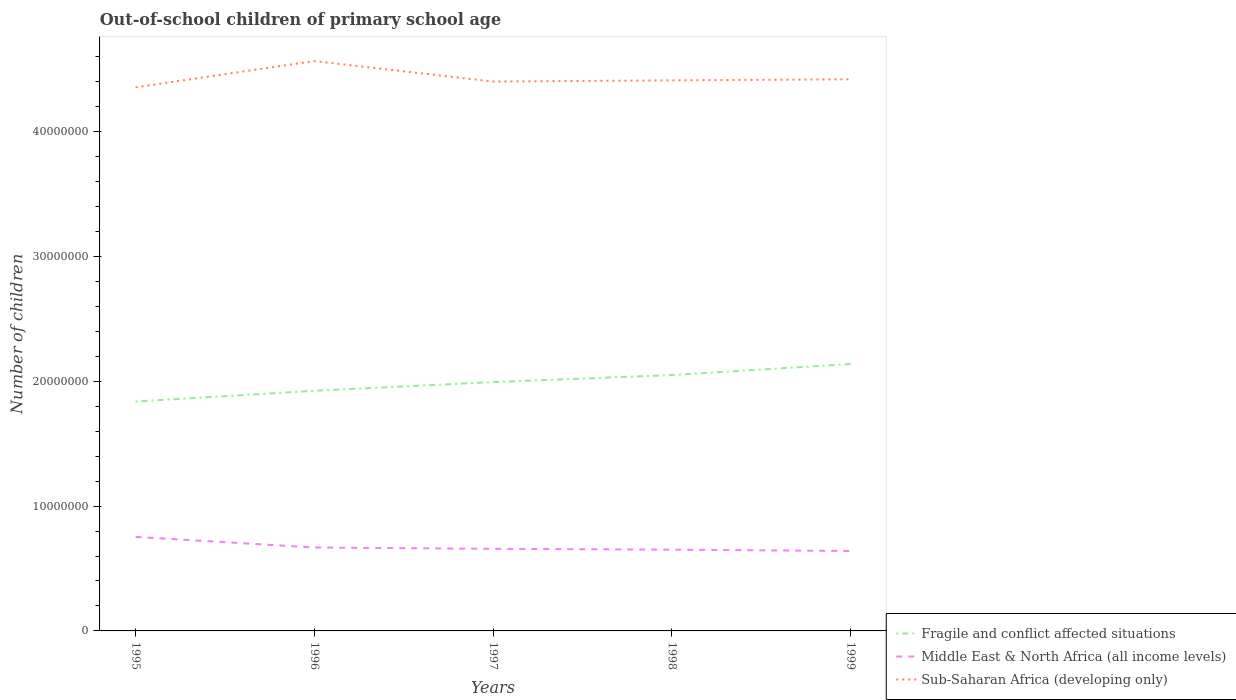Across all years, what is the maximum number of out-of-school children in Fragile and conflict affected situations?
Ensure brevity in your answer.  1.84e+07. What is the total number of out-of-school children in Sub-Saharan Africa (developing only) in the graph?
Your answer should be very brief. 1.54e+06. What is the difference between the highest and the second highest number of out-of-school children in Sub-Saharan Africa (developing only)?
Provide a short and direct response. 2.10e+06. What is the difference between the highest and the lowest number of out-of-school children in Fragile and conflict affected situations?
Ensure brevity in your answer.  3. Is the number of out-of-school children in Middle East & North Africa (all income levels) strictly greater than the number of out-of-school children in Sub-Saharan Africa (developing only) over the years?
Provide a short and direct response. Yes. How many years are there in the graph?
Give a very brief answer. 5. What is the difference between two consecutive major ticks on the Y-axis?
Make the answer very short. 1.00e+07. Does the graph contain grids?
Offer a terse response. No. How many legend labels are there?
Your answer should be very brief. 3. How are the legend labels stacked?
Provide a short and direct response. Vertical. What is the title of the graph?
Your answer should be compact. Out-of-school children of primary school age. What is the label or title of the Y-axis?
Give a very brief answer. Number of children. What is the Number of children in Fragile and conflict affected situations in 1995?
Make the answer very short. 1.84e+07. What is the Number of children of Middle East & North Africa (all income levels) in 1995?
Provide a short and direct response. 7.53e+06. What is the Number of children of Sub-Saharan Africa (developing only) in 1995?
Your answer should be compact. 4.35e+07. What is the Number of children in Fragile and conflict affected situations in 1996?
Keep it short and to the point. 1.92e+07. What is the Number of children of Middle East & North Africa (all income levels) in 1996?
Offer a very short reply. 6.68e+06. What is the Number of children in Sub-Saharan Africa (developing only) in 1996?
Provide a short and direct response. 4.56e+07. What is the Number of children of Fragile and conflict affected situations in 1997?
Your answer should be very brief. 1.99e+07. What is the Number of children in Middle East & North Africa (all income levels) in 1997?
Provide a succinct answer. 6.58e+06. What is the Number of children of Sub-Saharan Africa (developing only) in 1997?
Provide a succinct answer. 4.40e+07. What is the Number of children in Fragile and conflict affected situations in 1998?
Provide a short and direct response. 2.05e+07. What is the Number of children of Middle East & North Africa (all income levels) in 1998?
Provide a short and direct response. 6.51e+06. What is the Number of children of Sub-Saharan Africa (developing only) in 1998?
Give a very brief answer. 4.41e+07. What is the Number of children in Fragile and conflict affected situations in 1999?
Provide a succinct answer. 2.14e+07. What is the Number of children in Middle East & North Africa (all income levels) in 1999?
Your response must be concise. 6.40e+06. What is the Number of children in Sub-Saharan Africa (developing only) in 1999?
Provide a short and direct response. 4.42e+07. Across all years, what is the maximum Number of children of Fragile and conflict affected situations?
Provide a succinct answer. 2.14e+07. Across all years, what is the maximum Number of children of Middle East & North Africa (all income levels)?
Give a very brief answer. 7.53e+06. Across all years, what is the maximum Number of children of Sub-Saharan Africa (developing only)?
Your response must be concise. 4.56e+07. Across all years, what is the minimum Number of children in Fragile and conflict affected situations?
Give a very brief answer. 1.84e+07. Across all years, what is the minimum Number of children of Middle East & North Africa (all income levels)?
Keep it short and to the point. 6.40e+06. Across all years, what is the minimum Number of children of Sub-Saharan Africa (developing only)?
Keep it short and to the point. 4.35e+07. What is the total Number of children in Fragile and conflict affected situations in the graph?
Make the answer very short. 9.94e+07. What is the total Number of children of Middle East & North Africa (all income levels) in the graph?
Provide a short and direct response. 3.37e+07. What is the total Number of children of Sub-Saharan Africa (developing only) in the graph?
Offer a terse response. 2.21e+08. What is the difference between the Number of children in Fragile and conflict affected situations in 1995 and that in 1996?
Your answer should be compact. -8.56e+05. What is the difference between the Number of children of Middle East & North Africa (all income levels) in 1995 and that in 1996?
Your answer should be very brief. 8.50e+05. What is the difference between the Number of children of Sub-Saharan Africa (developing only) in 1995 and that in 1996?
Your answer should be compact. -2.10e+06. What is the difference between the Number of children of Fragile and conflict affected situations in 1995 and that in 1997?
Offer a terse response. -1.56e+06. What is the difference between the Number of children in Middle East & North Africa (all income levels) in 1995 and that in 1997?
Give a very brief answer. 9.55e+05. What is the difference between the Number of children in Sub-Saharan Africa (developing only) in 1995 and that in 1997?
Give a very brief answer. -4.59e+05. What is the difference between the Number of children of Fragile and conflict affected situations in 1995 and that in 1998?
Provide a short and direct response. -2.12e+06. What is the difference between the Number of children in Middle East & North Africa (all income levels) in 1995 and that in 1998?
Offer a terse response. 1.02e+06. What is the difference between the Number of children of Sub-Saharan Africa (developing only) in 1995 and that in 1998?
Keep it short and to the point. -5.56e+05. What is the difference between the Number of children in Fragile and conflict affected situations in 1995 and that in 1999?
Make the answer very short. -3.00e+06. What is the difference between the Number of children in Middle East & North Africa (all income levels) in 1995 and that in 1999?
Provide a succinct answer. 1.13e+06. What is the difference between the Number of children in Sub-Saharan Africa (developing only) in 1995 and that in 1999?
Keep it short and to the point. -6.39e+05. What is the difference between the Number of children in Fragile and conflict affected situations in 1996 and that in 1997?
Ensure brevity in your answer.  -7.00e+05. What is the difference between the Number of children of Middle East & North Africa (all income levels) in 1996 and that in 1997?
Give a very brief answer. 1.06e+05. What is the difference between the Number of children of Sub-Saharan Africa (developing only) in 1996 and that in 1997?
Make the answer very short. 1.64e+06. What is the difference between the Number of children in Fragile and conflict affected situations in 1996 and that in 1998?
Provide a short and direct response. -1.26e+06. What is the difference between the Number of children in Middle East & North Africa (all income levels) in 1996 and that in 1998?
Ensure brevity in your answer.  1.74e+05. What is the difference between the Number of children in Sub-Saharan Africa (developing only) in 1996 and that in 1998?
Offer a terse response. 1.54e+06. What is the difference between the Number of children in Fragile and conflict affected situations in 1996 and that in 1999?
Ensure brevity in your answer.  -2.15e+06. What is the difference between the Number of children of Middle East & North Africa (all income levels) in 1996 and that in 1999?
Your response must be concise. 2.80e+05. What is the difference between the Number of children of Sub-Saharan Africa (developing only) in 1996 and that in 1999?
Your answer should be very brief. 1.46e+06. What is the difference between the Number of children of Fragile and conflict affected situations in 1997 and that in 1998?
Make the answer very short. -5.61e+05. What is the difference between the Number of children in Middle East & North Africa (all income levels) in 1997 and that in 1998?
Keep it short and to the point. 6.80e+04. What is the difference between the Number of children of Sub-Saharan Africa (developing only) in 1997 and that in 1998?
Give a very brief answer. -9.67e+04. What is the difference between the Number of children of Fragile and conflict affected situations in 1997 and that in 1999?
Provide a succinct answer. -1.45e+06. What is the difference between the Number of children in Middle East & North Africa (all income levels) in 1997 and that in 1999?
Make the answer very short. 1.75e+05. What is the difference between the Number of children in Sub-Saharan Africa (developing only) in 1997 and that in 1999?
Make the answer very short. -1.79e+05. What is the difference between the Number of children in Fragile and conflict affected situations in 1998 and that in 1999?
Your answer should be very brief. -8.86e+05. What is the difference between the Number of children in Middle East & North Africa (all income levels) in 1998 and that in 1999?
Your answer should be very brief. 1.07e+05. What is the difference between the Number of children of Sub-Saharan Africa (developing only) in 1998 and that in 1999?
Ensure brevity in your answer.  -8.28e+04. What is the difference between the Number of children of Fragile and conflict affected situations in 1995 and the Number of children of Middle East & North Africa (all income levels) in 1996?
Your answer should be very brief. 1.17e+07. What is the difference between the Number of children of Fragile and conflict affected situations in 1995 and the Number of children of Sub-Saharan Africa (developing only) in 1996?
Give a very brief answer. -2.73e+07. What is the difference between the Number of children in Middle East & North Africa (all income levels) in 1995 and the Number of children in Sub-Saharan Africa (developing only) in 1996?
Offer a terse response. -3.81e+07. What is the difference between the Number of children of Fragile and conflict affected situations in 1995 and the Number of children of Middle East & North Africa (all income levels) in 1997?
Offer a terse response. 1.18e+07. What is the difference between the Number of children in Fragile and conflict affected situations in 1995 and the Number of children in Sub-Saharan Africa (developing only) in 1997?
Your response must be concise. -2.56e+07. What is the difference between the Number of children of Middle East & North Africa (all income levels) in 1995 and the Number of children of Sub-Saharan Africa (developing only) in 1997?
Offer a very short reply. -3.65e+07. What is the difference between the Number of children of Fragile and conflict affected situations in 1995 and the Number of children of Middle East & North Africa (all income levels) in 1998?
Provide a short and direct response. 1.19e+07. What is the difference between the Number of children in Fragile and conflict affected situations in 1995 and the Number of children in Sub-Saharan Africa (developing only) in 1998?
Give a very brief answer. -2.57e+07. What is the difference between the Number of children in Middle East & North Africa (all income levels) in 1995 and the Number of children in Sub-Saharan Africa (developing only) in 1998?
Your response must be concise. -3.66e+07. What is the difference between the Number of children in Fragile and conflict affected situations in 1995 and the Number of children in Middle East & North Africa (all income levels) in 1999?
Provide a short and direct response. 1.20e+07. What is the difference between the Number of children of Fragile and conflict affected situations in 1995 and the Number of children of Sub-Saharan Africa (developing only) in 1999?
Provide a short and direct response. -2.58e+07. What is the difference between the Number of children in Middle East & North Africa (all income levels) in 1995 and the Number of children in Sub-Saharan Africa (developing only) in 1999?
Keep it short and to the point. -3.67e+07. What is the difference between the Number of children of Fragile and conflict affected situations in 1996 and the Number of children of Middle East & North Africa (all income levels) in 1997?
Provide a short and direct response. 1.27e+07. What is the difference between the Number of children in Fragile and conflict affected situations in 1996 and the Number of children in Sub-Saharan Africa (developing only) in 1997?
Give a very brief answer. -2.48e+07. What is the difference between the Number of children in Middle East & North Africa (all income levels) in 1996 and the Number of children in Sub-Saharan Africa (developing only) in 1997?
Provide a succinct answer. -3.73e+07. What is the difference between the Number of children of Fragile and conflict affected situations in 1996 and the Number of children of Middle East & North Africa (all income levels) in 1998?
Your answer should be compact. 1.27e+07. What is the difference between the Number of children of Fragile and conflict affected situations in 1996 and the Number of children of Sub-Saharan Africa (developing only) in 1998?
Ensure brevity in your answer.  -2.49e+07. What is the difference between the Number of children of Middle East & North Africa (all income levels) in 1996 and the Number of children of Sub-Saharan Africa (developing only) in 1998?
Give a very brief answer. -3.74e+07. What is the difference between the Number of children in Fragile and conflict affected situations in 1996 and the Number of children in Middle East & North Africa (all income levels) in 1999?
Your answer should be compact. 1.28e+07. What is the difference between the Number of children in Fragile and conflict affected situations in 1996 and the Number of children in Sub-Saharan Africa (developing only) in 1999?
Provide a short and direct response. -2.50e+07. What is the difference between the Number of children of Middle East & North Africa (all income levels) in 1996 and the Number of children of Sub-Saharan Africa (developing only) in 1999?
Offer a terse response. -3.75e+07. What is the difference between the Number of children in Fragile and conflict affected situations in 1997 and the Number of children in Middle East & North Africa (all income levels) in 1998?
Keep it short and to the point. 1.34e+07. What is the difference between the Number of children of Fragile and conflict affected situations in 1997 and the Number of children of Sub-Saharan Africa (developing only) in 1998?
Your response must be concise. -2.42e+07. What is the difference between the Number of children in Middle East & North Africa (all income levels) in 1997 and the Number of children in Sub-Saharan Africa (developing only) in 1998?
Give a very brief answer. -3.75e+07. What is the difference between the Number of children of Fragile and conflict affected situations in 1997 and the Number of children of Middle East & North Africa (all income levels) in 1999?
Provide a succinct answer. 1.35e+07. What is the difference between the Number of children in Fragile and conflict affected situations in 1997 and the Number of children in Sub-Saharan Africa (developing only) in 1999?
Give a very brief answer. -2.43e+07. What is the difference between the Number of children in Middle East & North Africa (all income levels) in 1997 and the Number of children in Sub-Saharan Africa (developing only) in 1999?
Your response must be concise. -3.76e+07. What is the difference between the Number of children of Fragile and conflict affected situations in 1998 and the Number of children of Middle East & North Africa (all income levels) in 1999?
Give a very brief answer. 1.41e+07. What is the difference between the Number of children in Fragile and conflict affected situations in 1998 and the Number of children in Sub-Saharan Africa (developing only) in 1999?
Your answer should be very brief. -2.37e+07. What is the difference between the Number of children of Middle East & North Africa (all income levels) in 1998 and the Number of children of Sub-Saharan Africa (developing only) in 1999?
Keep it short and to the point. -3.77e+07. What is the average Number of children in Fragile and conflict affected situations per year?
Provide a succinct answer. 1.99e+07. What is the average Number of children of Middle East & North Africa (all income levels) per year?
Keep it short and to the point. 6.74e+06. What is the average Number of children of Sub-Saharan Africa (developing only) per year?
Ensure brevity in your answer.  4.43e+07. In the year 1995, what is the difference between the Number of children of Fragile and conflict affected situations and Number of children of Middle East & North Africa (all income levels)?
Keep it short and to the point. 1.08e+07. In the year 1995, what is the difference between the Number of children in Fragile and conflict affected situations and Number of children in Sub-Saharan Africa (developing only)?
Offer a terse response. -2.52e+07. In the year 1995, what is the difference between the Number of children in Middle East & North Africa (all income levels) and Number of children in Sub-Saharan Africa (developing only)?
Your answer should be compact. -3.60e+07. In the year 1996, what is the difference between the Number of children in Fragile and conflict affected situations and Number of children in Middle East & North Africa (all income levels)?
Your answer should be compact. 1.26e+07. In the year 1996, what is the difference between the Number of children of Fragile and conflict affected situations and Number of children of Sub-Saharan Africa (developing only)?
Give a very brief answer. -2.64e+07. In the year 1996, what is the difference between the Number of children in Middle East & North Africa (all income levels) and Number of children in Sub-Saharan Africa (developing only)?
Give a very brief answer. -3.90e+07. In the year 1997, what is the difference between the Number of children of Fragile and conflict affected situations and Number of children of Middle East & North Africa (all income levels)?
Give a very brief answer. 1.34e+07. In the year 1997, what is the difference between the Number of children of Fragile and conflict affected situations and Number of children of Sub-Saharan Africa (developing only)?
Your answer should be compact. -2.41e+07. In the year 1997, what is the difference between the Number of children of Middle East & North Africa (all income levels) and Number of children of Sub-Saharan Africa (developing only)?
Offer a terse response. -3.74e+07. In the year 1998, what is the difference between the Number of children in Fragile and conflict affected situations and Number of children in Middle East & North Africa (all income levels)?
Offer a very short reply. 1.40e+07. In the year 1998, what is the difference between the Number of children of Fragile and conflict affected situations and Number of children of Sub-Saharan Africa (developing only)?
Provide a succinct answer. -2.36e+07. In the year 1998, what is the difference between the Number of children of Middle East & North Africa (all income levels) and Number of children of Sub-Saharan Africa (developing only)?
Your answer should be compact. -3.76e+07. In the year 1999, what is the difference between the Number of children in Fragile and conflict affected situations and Number of children in Middle East & North Africa (all income levels)?
Your answer should be very brief. 1.50e+07. In the year 1999, what is the difference between the Number of children of Fragile and conflict affected situations and Number of children of Sub-Saharan Africa (developing only)?
Your response must be concise. -2.28e+07. In the year 1999, what is the difference between the Number of children of Middle East & North Africa (all income levels) and Number of children of Sub-Saharan Africa (developing only)?
Your response must be concise. -3.78e+07. What is the ratio of the Number of children in Fragile and conflict affected situations in 1995 to that in 1996?
Provide a short and direct response. 0.96. What is the ratio of the Number of children of Middle East & North Africa (all income levels) in 1995 to that in 1996?
Provide a short and direct response. 1.13. What is the ratio of the Number of children of Sub-Saharan Africa (developing only) in 1995 to that in 1996?
Give a very brief answer. 0.95. What is the ratio of the Number of children of Fragile and conflict affected situations in 1995 to that in 1997?
Offer a very short reply. 0.92. What is the ratio of the Number of children in Middle East & North Africa (all income levels) in 1995 to that in 1997?
Give a very brief answer. 1.15. What is the ratio of the Number of children of Fragile and conflict affected situations in 1995 to that in 1998?
Offer a terse response. 0.9. What is the ratio of the Number of children in Middle East & North Africa (all income levels) in 1995 to that in 1998?
Offer a very short reply. 1.16. What is the ratio of the Number of children of Sub-Saharan Africa (developing only) in 1995 to that in 1998?
Make the answer very short. 0.99. What is the ratio of the Number of children in Fragile and conflict affected situations in 1995 to that in 1999?
Ensure brevity in your answer.  0.86. What is the ratio of the Number of children in Middle East & North Africa (all income levels) in 1995 to that in 1999?
Give a very brief answer. 1.18. What is the ratio of the Number of children of Sub-Saharan Africa (developing only) in 1995 to that in 1999?
Ensure brevity in your answer.  0.99. What is the ratio of the Number of children of Fragile and conflict affected situations in 1996 to that in 1997?
Ensure brevity in your answer.  0.96. What is the ratio of the Number of children in Middle East & North Africa (all income levels) in 1996 to that in 1997?
Offer a very short reply. 1.02. What is the ratio of the Number of children of Sub-Saharan Africa (developing only) in 1996 to that in 1997?
Ensure brevity in your answer.  1.04. What is the ratio of the Number of children in Fragile and conflict affected situations in 1996 to that in 1998?
Provide a succinct answer. 0.94. What is the ratio of the Number of children in Middle East & North Africa (all income levels) in 1996 to that in 1998?
Make the answer very short. 1.03. What is the ratio of the Number of children of Sub-Saharan Africa (developing only) in 1996 to that in 1998?
Provide a succinct answer. 1.03. What is the ratio of the Number of children of Fragile and conflict affected situations in 1996 to that in 1999?
Make the answer very short. 0.9. What is the ratio of the Number of children in Middle East & North Africa (all income levels) in 1996 to that in 1999?
Keep it short and to the point. 1.04. What is the ratio of the Number of children in Sub-Saharan Africa (developing only) in 1996 to that in 1999?
Provide a succinct answer. 1.03. What is the ratio of the Number of children of Fragile and conflict affected situations in 1997 to that in 1998?
Ensure brevity in your answer.  0.97. What is the ratio of the Number of children of Middle East & North Africa (all income levels) in 1997 to that in 1998?
Keep it short and to the point. 1.01. What is the ratio of the Number of children of Sub-Saharan Africa (developing only) in 1997 to that in 1998?
Give a very brief answer. 1. What is the ratio of the Number of children of Fragile and conflict affected situations in 1997 to that in 1999?
Your answer should be compact. 0.93. What is the ratio of the Number of children in Middle East & North Africa (all income levels) in 1997 to that in 1999?
Provide a short and direct response. 1.03. What is the ratio of the Number of children in Fragile and conflict affected situations in 1998 to that in 1999?
Provide a short and direct response. 0.96. What is the ratio of the Number of children of Middle East & North Africa (all income levels) in 1998 to that in 1999?
Ensure brevity in your answer.  1.02. What is the ratio of the Number of children of Sub-Saharan Africa (developing only) in 1998 to that in 1999?
Keep it short and to the point. 1. What is the difference between the highest and the second highest Number of children in Fragile and conflict affected situations?
Keep it short and to the point. 8.86e+05. What is the difference between the highest and the second highest Number of children in Middle East & North Africa (all income levels)?
Your response must be concise. 8.50e+05. What is the difference between the highest and the second highest Number of children in Sub-Saharan Africa (developing only)?
Provide a short and direct response. 1.46e+06. What is the difference between the highest and the lowest Number of children in Fragile and conflict affected situations?
Provide a succinct answer. 3.00e+06. What is the difference between the highest and the lowest Number of children of Middle East & North Africa (all income levels)?
Your answer should be compact. 1.13e+06. What is the difference between the highest and the lowest Number of children of Sub-Saharan Africa (developing only)?
Make the answer very short. 2.10e+06. 